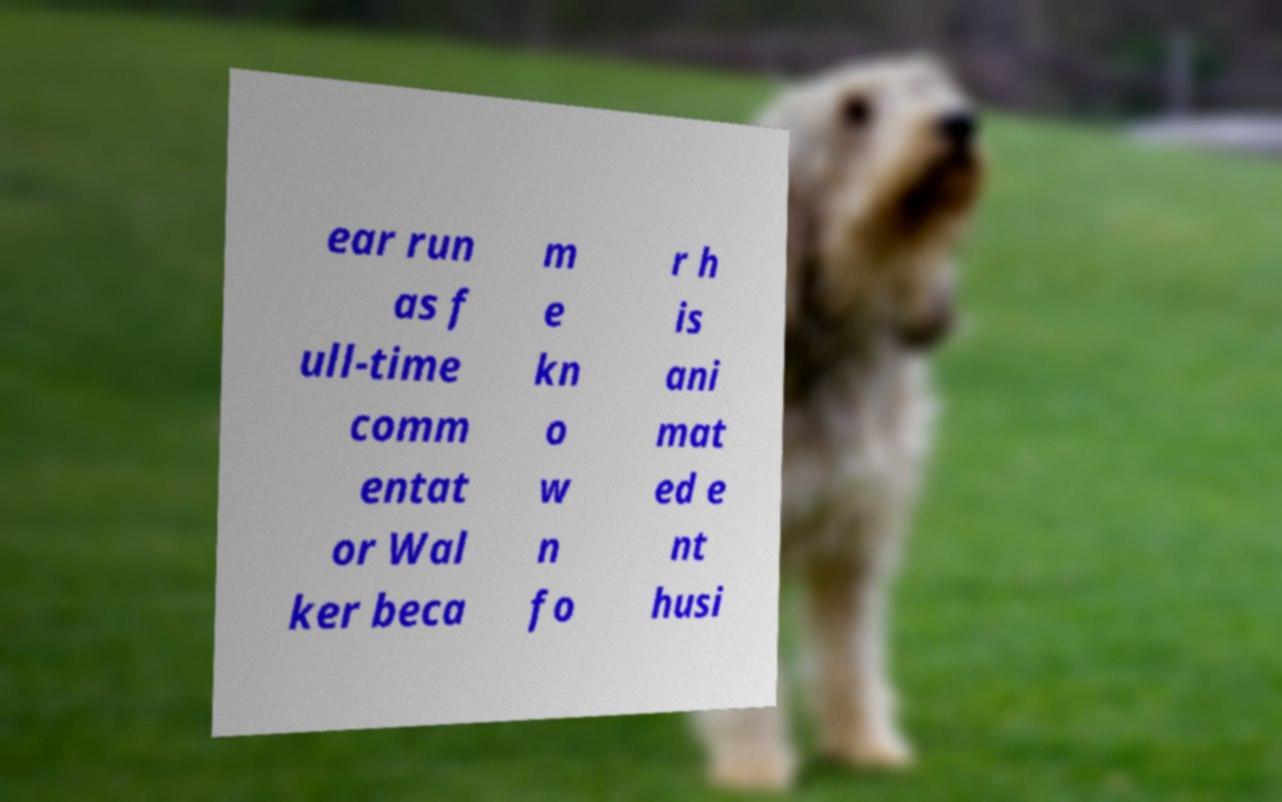Can you read and provide the text displayed in the image?This photo seems to have some interesting text. Can you extract and type it out for me? ear run as f ull-time comm entat or Wal ker beca m e kn o w n fo r h is ani mat ed e nt husi 